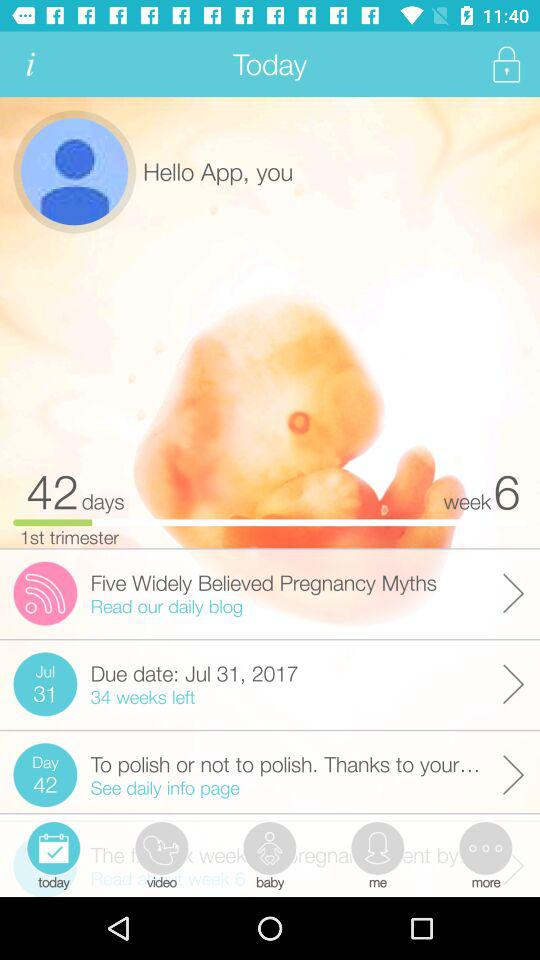What are the myths about pregnancy?
When the provided information is insufficient, respond with <no answer>. <no answer> 